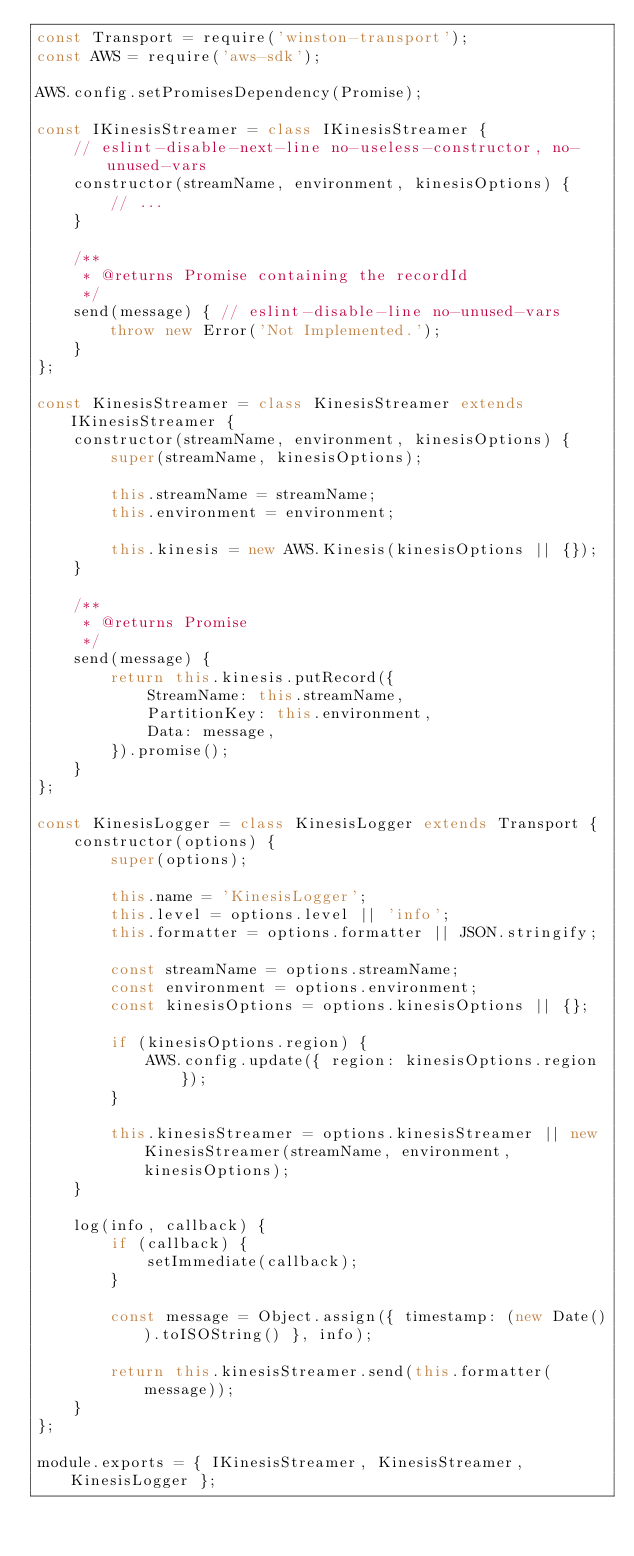Convert code to text. <code><loc_0><loc_0><loc_500><loc_500><_JavaScript_>const Transport = require('winston-transport');
const AWS = require('aws-sdk');

AWS.config.setPromisesDependency(Promise);

const IKinesisStreamer = class IKinesisStreamer {
    // eslint-disable-next-line no-useless-constructor, no-unused-vars
    constructor(streamName, environment, kinesisOptions) {
        // ...
    }

    /**
     * @returns Promise containing the recordId
     */
    send(message) { // eslint-disable-line no-unused-vars
        throw new Error('Not Implemented.');
    }
};

const KinesisStreamer = class KinesisStreamer extends IKinesisStreamer {
    constructor(streamName, environment, kinesisOptions) {
        super(streamName, kinesisOptions);

        this.streamName = streamName;
        this.environment = environment;

        this.kinesis = new AWS.Kinesis(kinesisOptions || {});
    }

    /**
     * @returns Promise
     */
    send(message) {
        return this.kinesis.putRecord({
            StreamName: this.streamName,
            PartitionKey: this.environment,
            Data: message,
        }).promise();
    }
};

const KinesisLogger = class KinesisLogger extends Transport {
    constructor(options) {
        super(options);

        this.name = 'KinesisLogger';
        this.level = options.level || 'info';
        this.formatter = options.formatter || JSON.stringify;

        const streamName = options.streamName;
        const environment = options.environment;
        const kinesisOptions = options.kinesisOptions || {};

        if (kinesisOptions.region) {
            AWS.config.update({ region: kinesisOptions.region });
        }

        this.kinesisStreamer = options.kinesisStreamer || new KinesisStreamer(streamName, environment, kinesisOptions);
    }

    log(info, callback) {
        if (callback) {
            setImmediate(callback);
        }

        const message = Object.assign({ timestamp: (new Date()).toISOString() }, info);

        return this.kinesisStreamer.send(this.formatter(message));
    }
};

module.exports = { IKinesisStreamer, KinesisStreamer, KinesisLogger };
</code> 